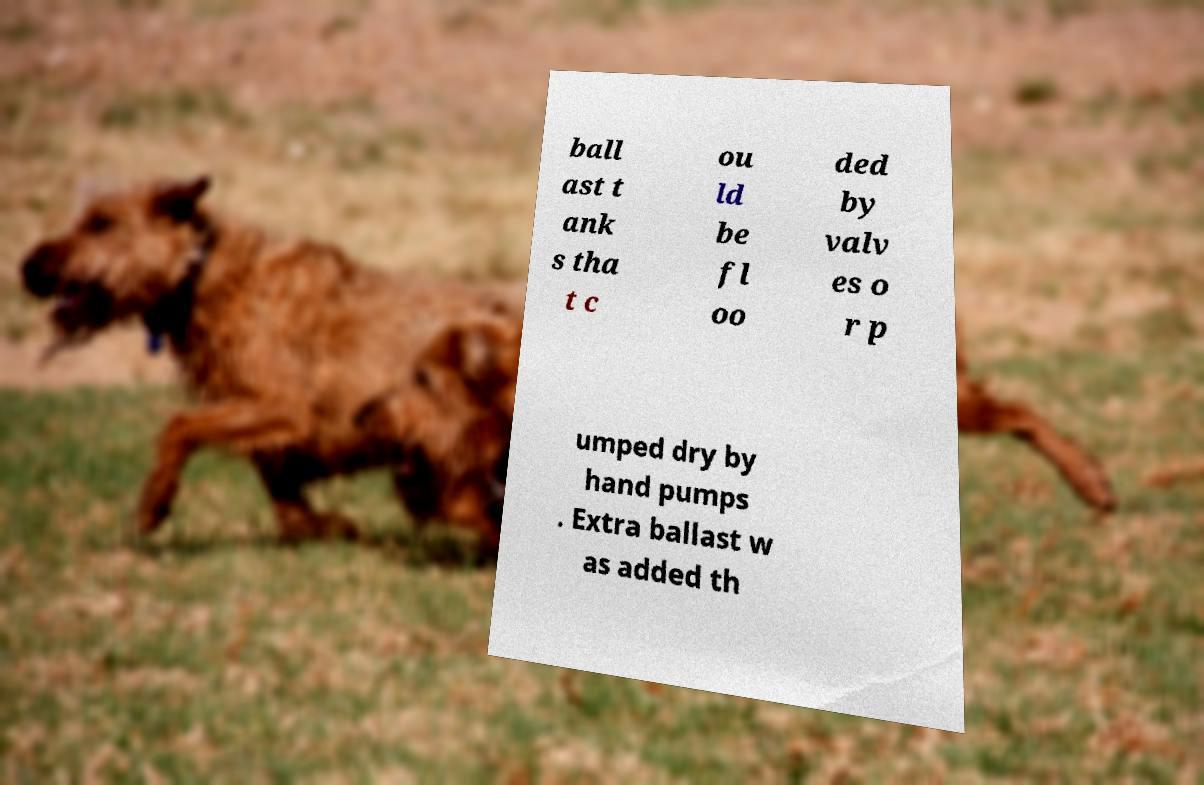Can you accurately transcribe the text from the provided image for me? ball ast t ank s tha t c ou ld be fl oo ded by valv es o r p umped dry by hand pumps . Extra ballast w as added th 